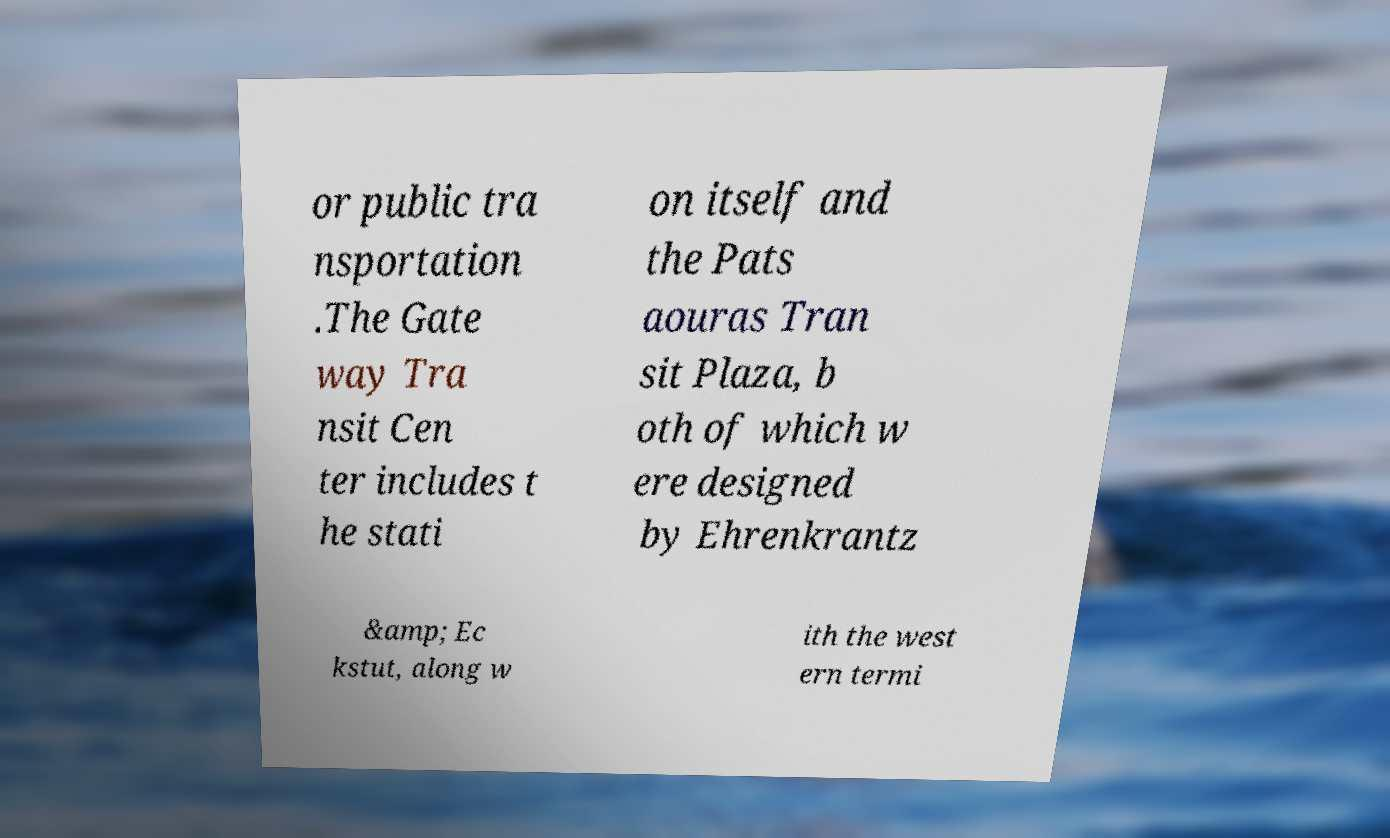Can you accurately transcribe the text from the provided image for me? or public tra nsportation .The Gate way Tra nsit Cen ter includes t he stati on itself and the Pats aouras Tran sit Plaza, b oth of which w ere designed by Ehrenkrantz &amp; Ec kstut, along w ith the west ern termi 